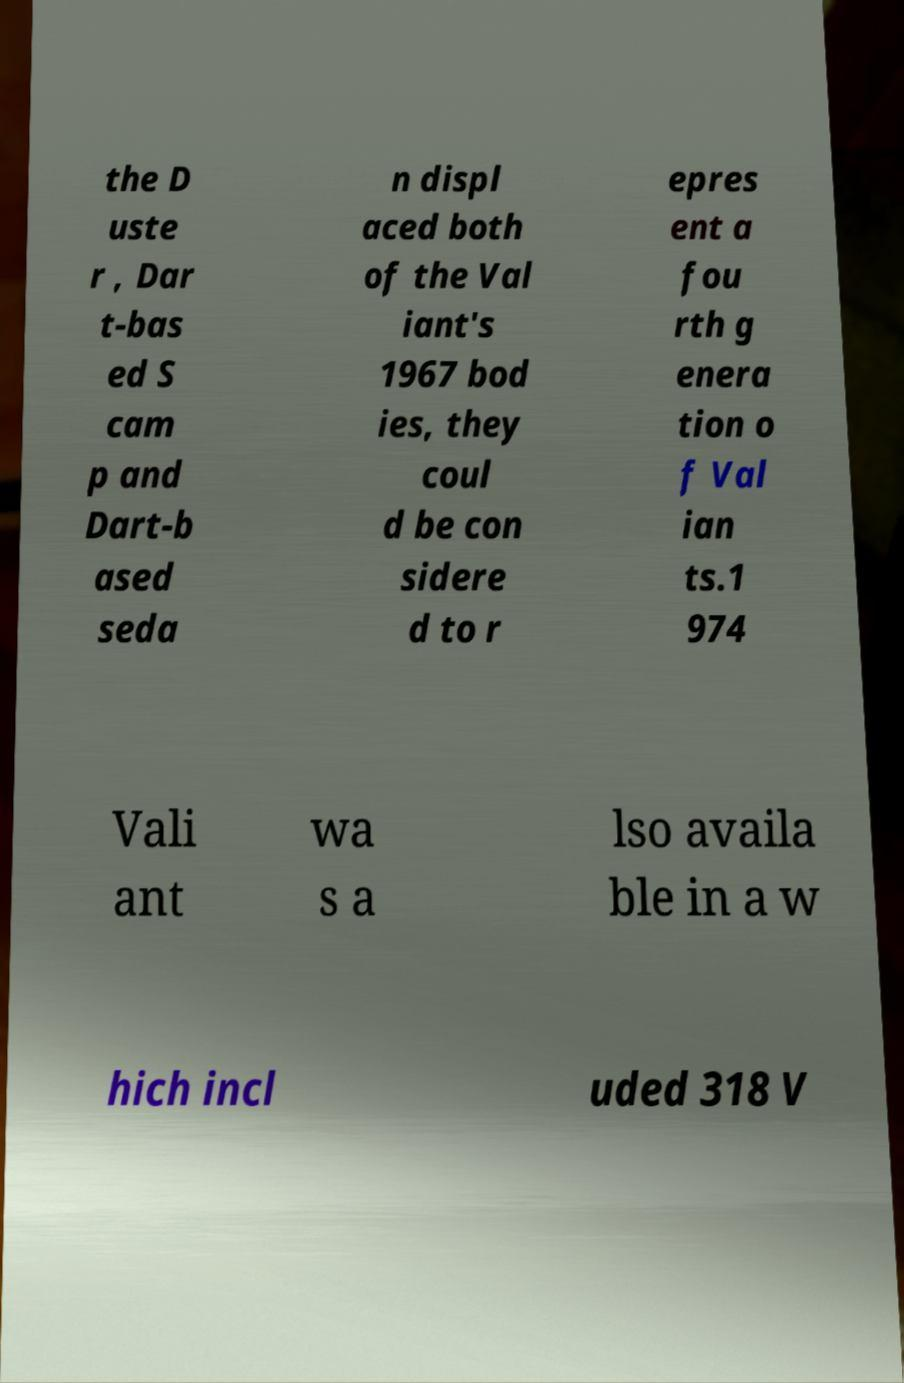For documentation purposes, I need the text within this image transcribed. Could you provide that? the D uste r , Dar t-bas ed S cam p and Dart-b ased seda n displ aced both of the Val iant's 1967 bod ies, they coul d be con sidere d to r epres ent a fou rth g enera tion o f Val ian ts.1 974 Vali ant wa s a lso availa ble in a w hich incl uded 318 V 